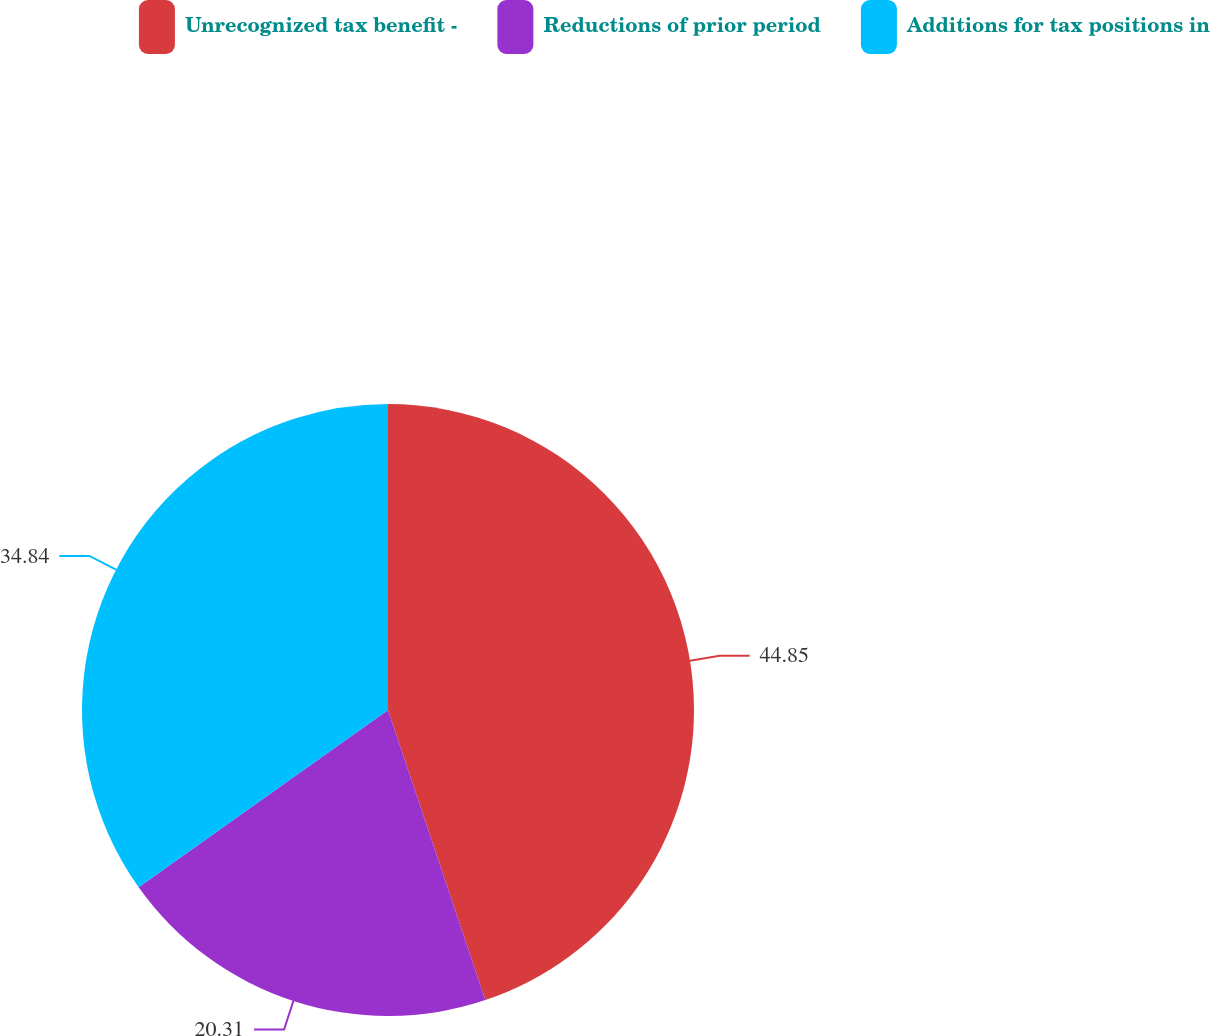<chart> <loc_0><loc_0><loc_500><loc_500><pie_chart><fcel>Unrecognized tax benefit -<fcel>Reductions of prior period<fcel>Additions for tax positions in<nl><fcel>44.85%<fcel>20.31%<fcel>34.84%<nl></chart> 